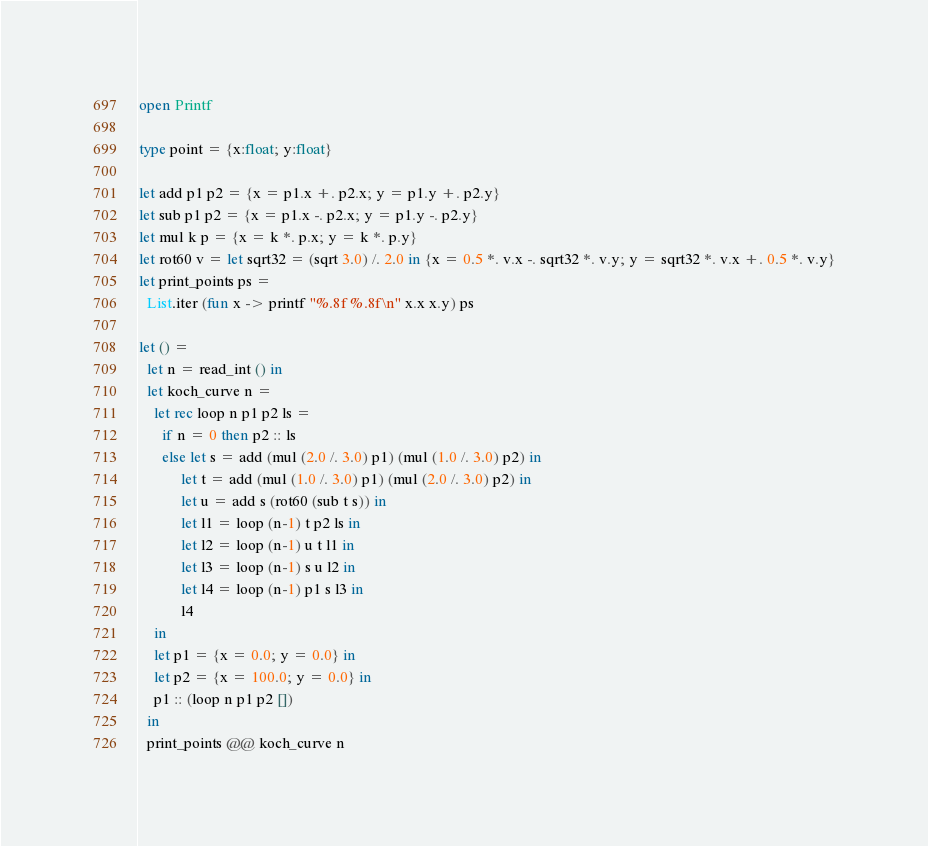Convert code to text. <code><loc_0><loc_0><loc_500><loc_500><_OCaml_>open Printf
       
type point = {x:float; y:float}

let add p1 p2 = {x = p1.x +. p2.x; y = p1.y +. p2.y}
let sub p1 p2 = {x = p1.x -. p2.x; y = p1.y -. p2.y}
let mul k p = {x = k *. p.x; y = k *. p.y}
let rot60 v = let sqrt32 = (sqrt 3.0) /. 2.0 in {x = 0.5 *. v.x -. sqrt32 *. v.y; y = sqrt32 *. v.x +. 0.5 *. v.y}
let print_points ps =
  List.iter (fun x -> printf "%.8f %.8f\n" x.x x.y) ps

let () =
  let n = read_int () in
  let koch_curve n =
    let rec loop n p1 p2 ls =
      if n = 0 then p2 :: ls
      else let s = add (mul (2.0 /. 3.0) p1) (mul (1.0 /. 3.0) p2) in
           let t = add (mul (1.0 /. 3.0) p1) (mul (2.0 /. 3.0) p2) in
           let u = add s (rot60 (sub t s)) in
           let l1 = loop (n-1) t p2 ls in
           let l2 = loop (n-1) u t l1 in
           let l3 = loop (n-1) s u l2 in
           let l4 = loop (n-1) p1 s l3 in
           l4
    in
    let p1 = {x = 0.0; y = 0.0} in
    let p2 = {x = 100.0; y = 0.0} in
    p1 :: (loop n p1 p2 [])
  in
  print_points @@ koch_curve n</code> 